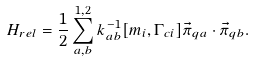<formula> <loc_0><loc_0><loc_500><loc_500>H _ { r e l } = { \frac { 1 } { 2 } } \sum _ { a , b } ^ { 1 , 2 } k _ { a b } ^ { - 1 } [ m _ { i } , \Gamma _ { c i } ] { \vec { \pi } } _ { q a } \cdot { \vec { \pi } } _ { q b } .</formula> 